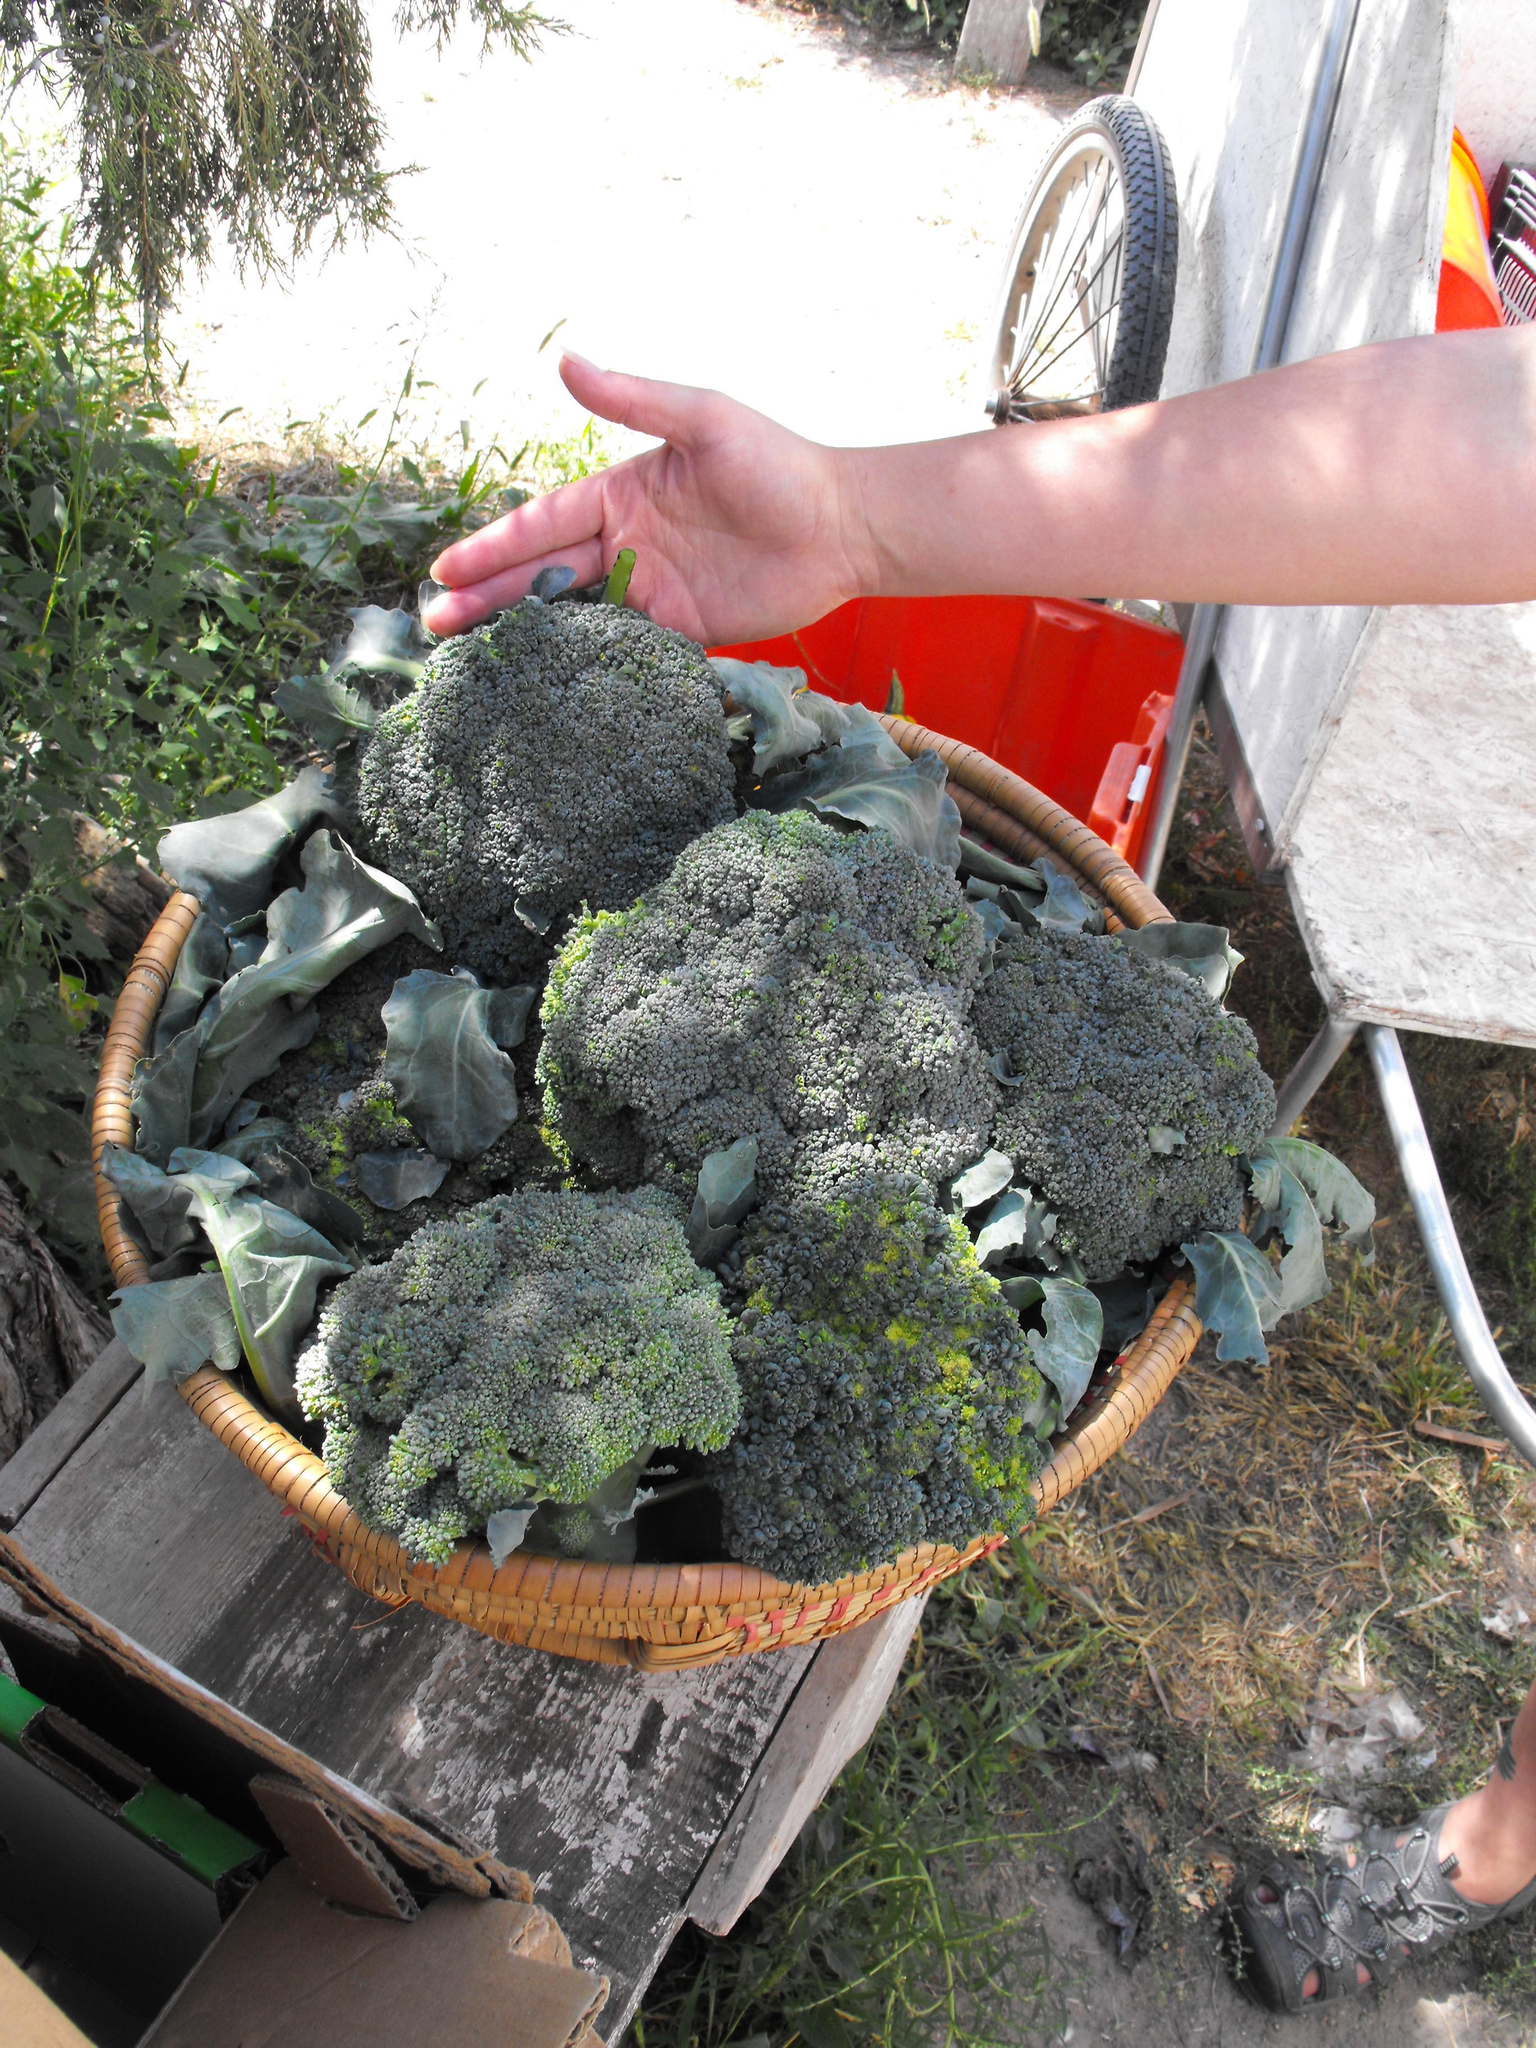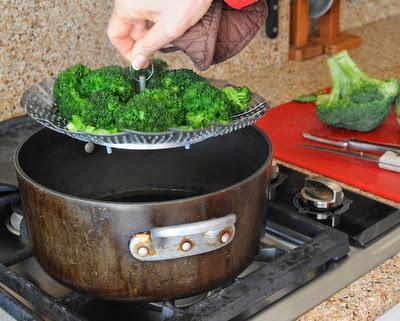The first image is the image on the left, the second image is the image on the right. For the images displayed, is the sentence "All images show broccoli in a round container of some type." factually correct? Answer yes or no. Yes. The first image is the image on the left, the second image is the image on the right. Considering the images on both sides, is "There is a human head in the image on the right." valid? Answer yes or no. No. 